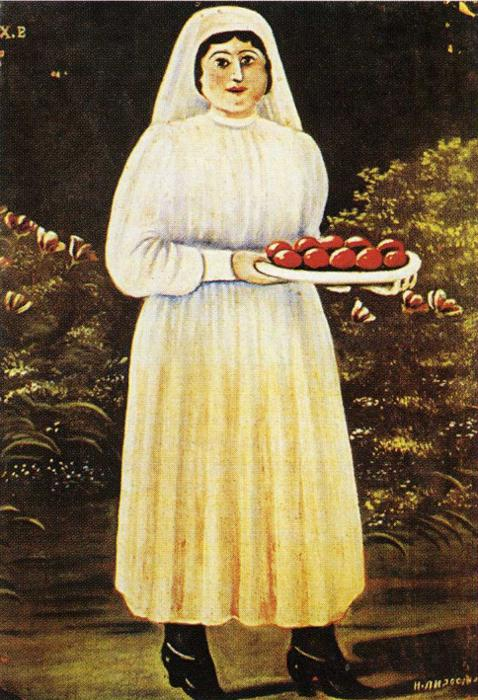Imagine if this painting could transform into an animated film; what would happen? In the animated film adaptation, the painting would come to life, revealing a lush and lively village scene. Birds would flit about, and the tree would sway gently in the breeze. The woman, now animated, would be seen carefully tending to her garden, her tray of apples a product of her dedication. As she moves through her day, she encounters various village characters, each with their own stories and contributions to the communal harvest. The film would focus on themes of community, hard work, and the cyclical beauty of nature, with vibrant colors and emotive music reflecting the changing seasons and the collective heart of the village. 